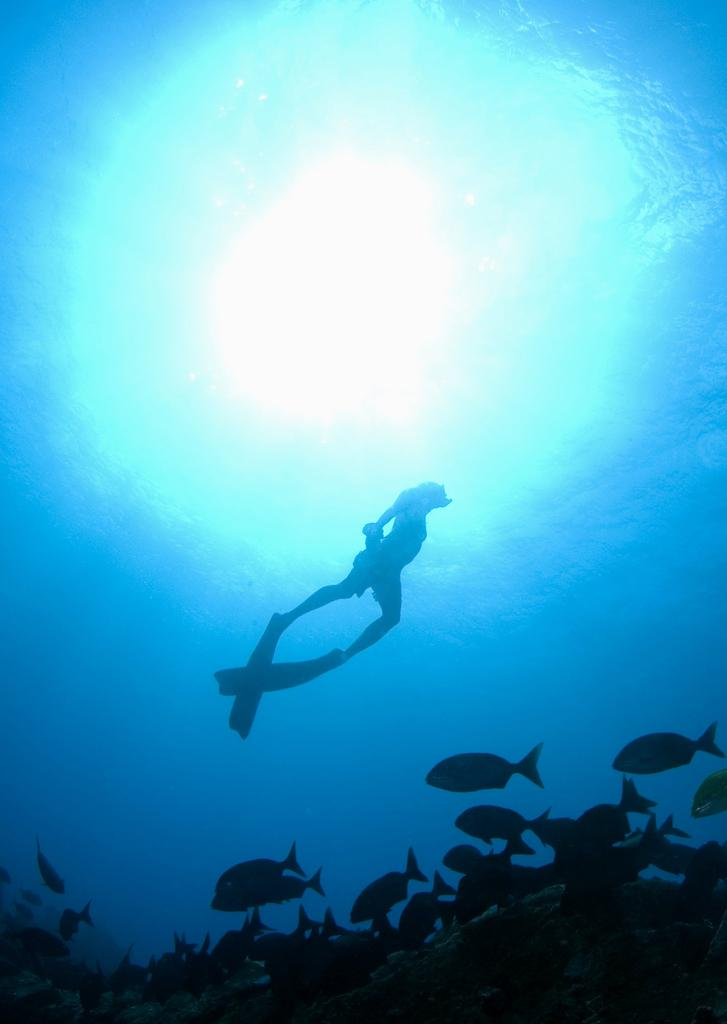What activity is being depicted in the image? The image depicts scuba diving. Can you describe the person in the image? There is a person in the middle of the image. What is the environment like in the image? There is water visible in the image. What other living organisms can be seen in the image? There are fishes at the bottom of the image. What topic is the person talking about while scuba diving in the image? There is no indication in the image that the person is talking while scuba diving. --- 